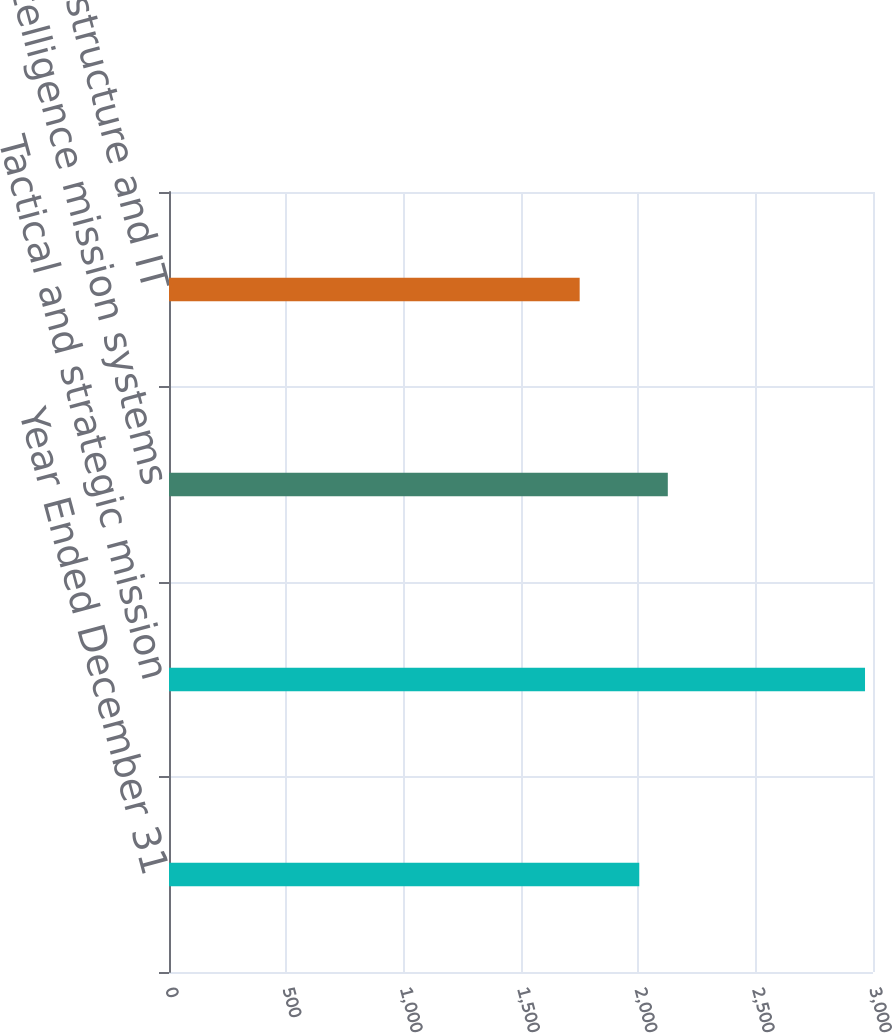<chart> <loc_0><loc_0><loc_500><loc_500><bar_chart><fcel>Year Ended December 31<fcel>Tactical and strategic mission<fcel>Intelligence mission systems<fcel>Network infrastructure and IT<nl><fcel>2004<fcel>2966<fcel>2125.6<fcel>1750<nl></chart> 